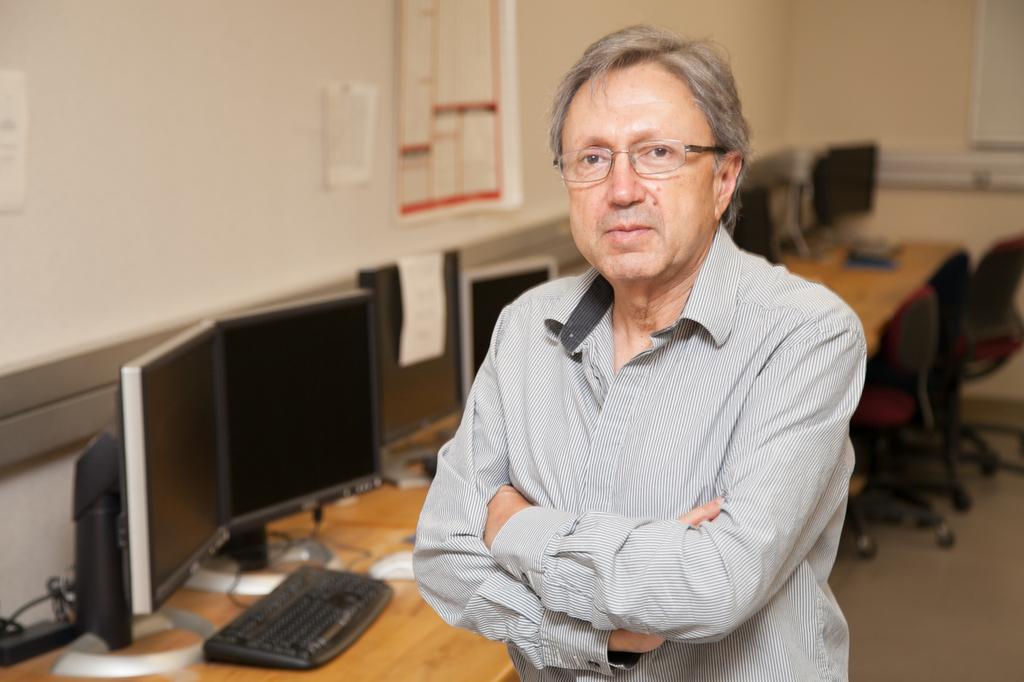Could you give a brief overview of what you see in this image? In this image we can see persons standing on the floor. In the background we can see monitors, keyboards, tables, chairs, board, calendar and wall. 